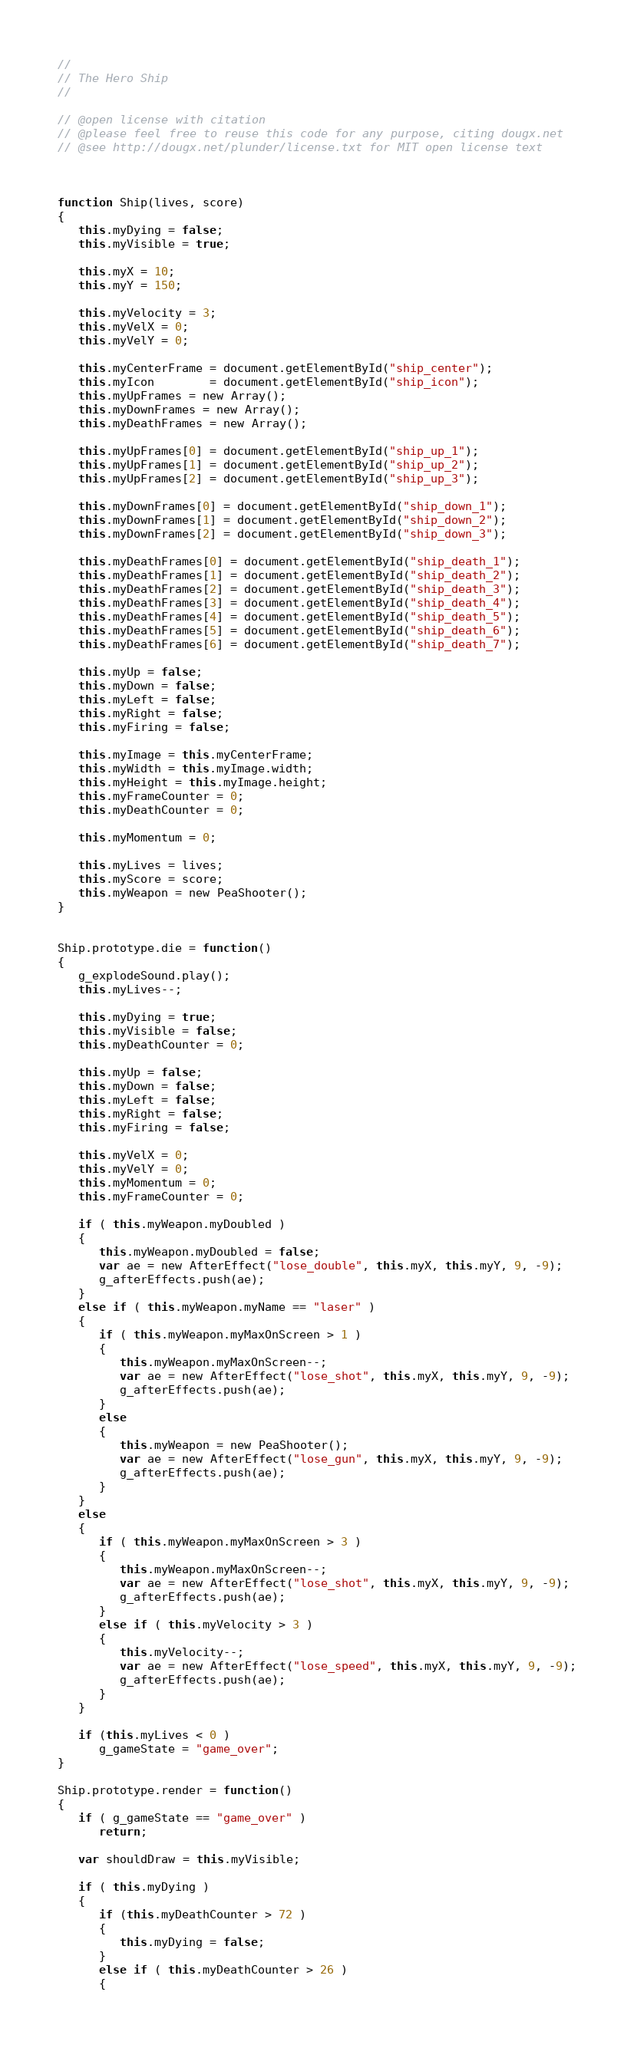Convert code to text. <code><loc_0><loc_0><loc_500><loc_500><_JavaScript_>//
// The Hero Ship
//

// @open license with citation
// @please feel free to reuse this code for any purpose, citing dougx.net
// @see http://dougx.net/plunder/license.txt for MIT open license text



function Ship(lives, score)
{
   this.myDying = false;
   this.myVisible = true;

   this.myX = 10;
   this.myY = 150;

   this.myVelocity = 3;
   this.myVelX = 0;
   this.myVelY = 0;

   this.myCenterFrame = document.getElementById("ship_center");
   this.myIcon        = document.getElementById("ship_icon");
   this.myUpFrames = new Array();
   this.myDownFrames = new Array();
   this.myDeathFrames = new Array();

   this.myUpFrames[0] = document.getElementById("ship_up_1");
   this.myUpFrames[1] = document.getElementById("ship_up_2");
   this.myUpFrames[2] = document.getElementById("ship_up_3");

   this.myDownFrames[0] = document.getElementById("ship_down_1");
   this.myDownFrames[1] = document.getElementById("ship_down_2");
   this.myDownFrames[2] = document.getElementById("ship_down_3");

   this.myDeathFrames[0] = document.getElementById("ship_death_1");
   this.myDeathFrames[1] = document.getElementById("ship_death_2");
   this.myDeathFrames[2] = document.getElementById("ship_death_3");
   this.myDeathFrames[3] = document.getElementById("ship_death_4");
   this.myDeathFrames[4] = document.getElementById("ship_death_5");
   this.myDeathFrames[5] = document.getElementById("ship_death_6");
   this.myDeathFrames[6] = document.getElementById("ship_death_7");

   this.myUp = false;
   this.myDown = false;
   this.myLeft = false;
   this.myRight = false;
   this.myFiring = false;

   this.myImage = this.myCenterFrame;
   this.myWidth = this.myImage.width;
   this.myHeight = this.myImage.height;
   this.myFrameCounter = 0;
   this.myDeathCounter = 0;

   this.myMomentum = 0;

   this.myLives = lives;
   this.myScore = score;
   this.myWeapon = new PeaShooter();
}


Ship.prototype.die = function()
{
   g_explodeSound.play();
   this.myLives--;

   this.myDying = true;
   this.myVisible = false;
   this.myDeathCounter = 0;

   this.myUp = false;
   this.myDown = false;
   this.myLeft = false;
   this.myRight = false;
   this.myFiring = false;

   this.myVelX = 0;
   this.myVelY = 0;
   this.myMomentum = 0;
   this.myFrameCounter = 0;

   if ( this.myWeapon.myDoubled )
   {
      this.myWeapon.myDoubled = false;
      var ae = new AfterEffect("lose_double", this.myX, this.myY, 9, -9);
      g_afterEffects.push(ae);
   }
   else if ( this.myWeapon.myName == "laser" )
   {
      if ( this.myWeapon.myMaxOnScreen > 1 )
      {
         this.myWeapon.myMaxOnScreen--;
         var ae = new AfterEffect("lose_shot", this.myX, this.myY, 9, -9);
         g_afterEffects.push(ae);
      }
      else
      {
         this.myWeapon = new PeaShooter();
         var ae = new AfterEffect("lose_gun", this.myX, this.myY, 9, -9);
         g_afterEffects.push(ae);
      }
   }
   else
   {
      if ( this.myWeapon.myMaxOnScreen > 3 )
      {
         this.myWeapon.myMaxOnScreen--;
         var ae = new AfterEffect("lose_shot", this.myX, this.myY, 9, -9);
         g_afterEffects.push(ae);
      }
      else if ( this.myVelocity > 3 )
      {
         this.myVelocity--;
         var ae = new AfterEffect("lose_speed", this.myX, this.myY, 9, -9);
         g_afterEffects.push(ae);
      }
   }

   if (this.myLives < 0 )
      g_gameState = "game_over";
}

Ship.prototype.render = function()
{
   if ( g_gameState == "game_over" )
      return;

   var shouldDraw = this.myVisible;

   if ( this.myDying )
   {
      if (this.myDeathCounter > 72 )
      {
         this.myDying = false;
      }
      else if ( this.myDeathCounter > 26 )
      {</code> 